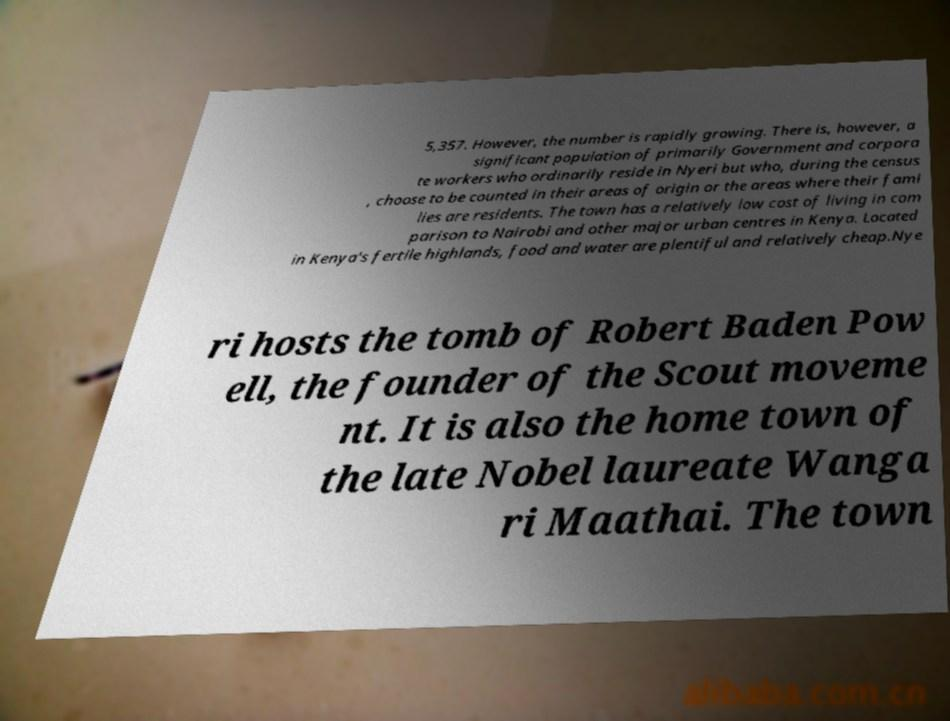Can you read and provide the text displayed in the image?This photo seems to have some interesting text. Can you extract and type it out for me? 5,357. However, the number is rapidly growing. There is, however, a significant population of primarily Government and corpora te workers who ordinarily reside in Nyeri but who, during the census , choose to be counted in their areas of origin or the areas where their fami lies are residents. The town has a relatively low cost of living in com parison to Nairobi and other major urban centres in Kenya. Located in Kenya's fertile highlands, food and water are plentiful and relatively cheap.Nye ri hosts the tomb of Robert Baden Pow ell, the founder of the Scout moveme nt. It is also the home town of the late Nobel laureate Wanga ri Maathai. The town 